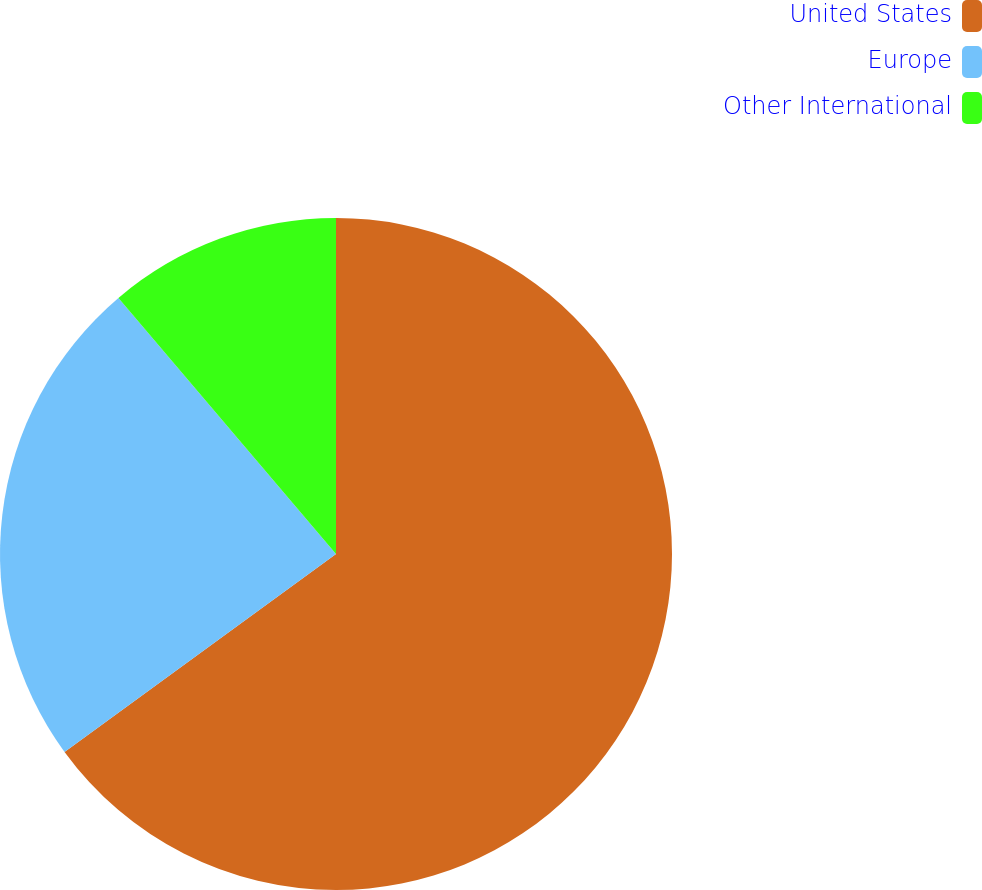Convert chart to OTSL. <chart><loc_0><loc_0><loc_500><loc_500><pie_chart><fcel>United States<fcel>Europe<fcel>Other International<nl><fcel>64.97%<fcel>23.82%<fcel>11.21%<nl></chart> 